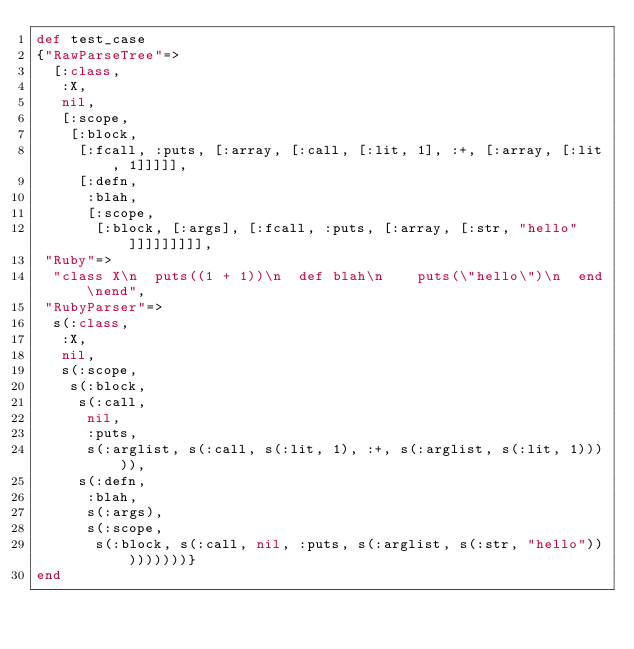Convert code to text. <code><loc_0><loc_0><loc_500><loc_500><_Ruby_>def test_case
{"RawParseTree"=>
  [:class,
   :X,
   nil,
   [:scope,
    [:block,
     [:fcall, :puts, [:array, [:call, [:lit, 1], :+, [:array, [:lit, 1]]]]],
     [:defn,
      :blah,
      [:scope,
       [:block, [:args], [:fcall, :puts, [:array, [:str, "hello"]]]]]]]]],
 "Ruby"=>
  "class X\n  puts((1 + 1))\n  def blah\n    puts(\"hello\")\n  end\nend",
 "RubyParser"=>
  s(:class,
   :X,
   nil,
   s(:scope,
    s(:block,
     s(:call,
      nil,
      :puts,
      s(:arglist, s(:call, s(:lit, 1), :+, s(:arglist, s(:lit, 1))))),
     s(:defn,
      :blah,
      s(:args),
      s(:scope,
       s(:block, s(:call, nil, :puts, s(:arglist, s(:str, "hello")))))))))}
end
</code> 